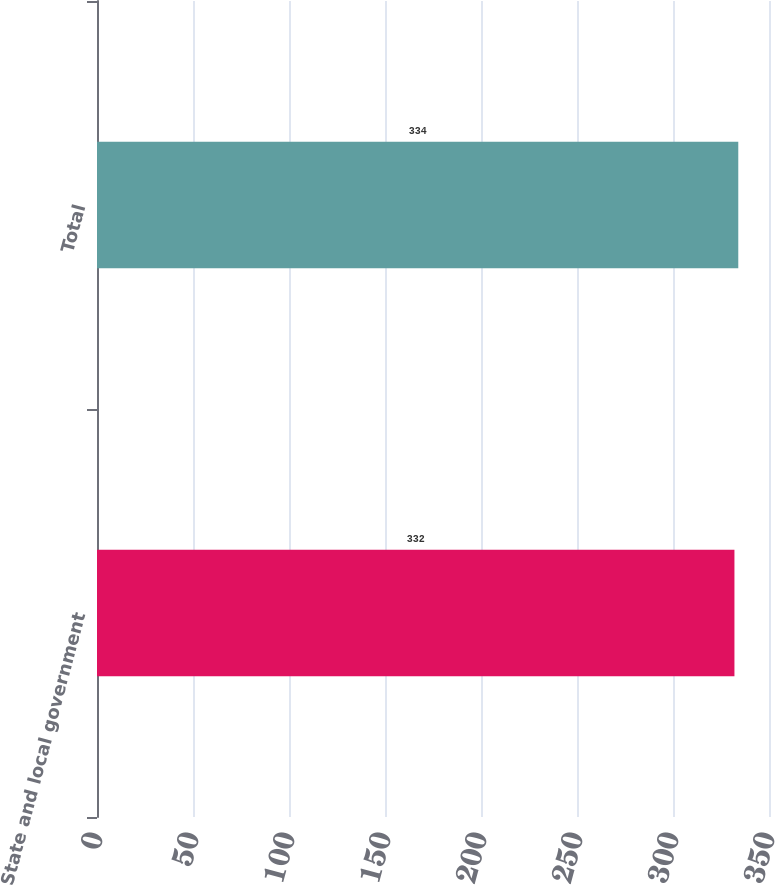<chart> <loc_0><loc_0><loc_500><loc_500><bar_chart><fcel>State and local government<fcel>Total<nl><fcel>332<fcel>334<nl></chart> 